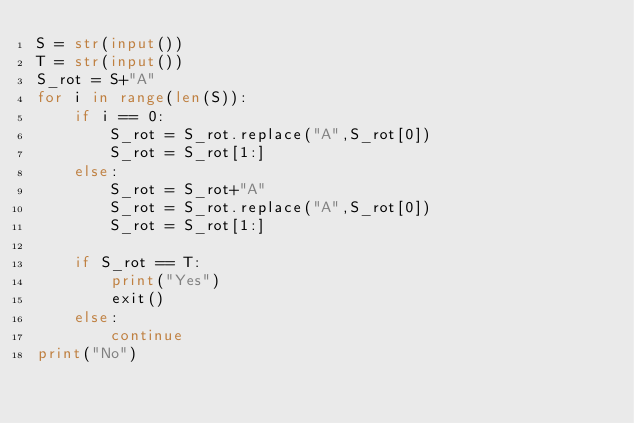Convert code to text. <code><loc_0><loc_0><loc_500><loc_500><_Python_>S = str(input())
T = str(input()) 
S_rot = S+"A"
for i in range(len(S)):
    if i == 0:
        S_rot = S_rot.replace("A",S_rot[0])
        S_rot = S_rot[1:]
    else:
        S_rot = S_rot+"A"
        S_rot = S_rot.replace("A",S_rot[0])
        S_rot = S_rot[1:]

    if S_rot == T:
        print("Yes")
        exit()
    else:
        continue
print("No")</code> 